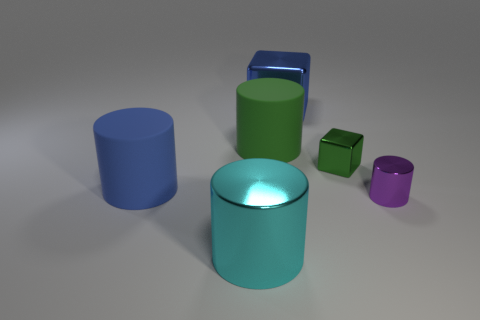What material is the thing that is behind the big blue cylinder and in front of the big green cylinder?
Provide a succinct answer. Metal. Are the cyan cylinder and the blue block that is on the left side of the small purple thing made of the same material?
Your answer should be compact. Yes. Are there any other things that are the same size as the cyan cylinder?
Give a very brief answer. Yes. How many things are either small cubes or cylinders that are in front of the blue rubber cylinder?
Your response must be concise. 3. Is the size of the matte cylinder that is to the right of the cyan shiny cylinder the same as the metal cylinder on the right side of the big block?
Provide a short and direct response. No. How many other things are there of the same color as the big metallic cylinder?
Your answer should be very brief. 0. There is a green cylinder; is its size the same as the cylinder that is to the right of the green cube?
Give a very brief answer. No. There is a blue object behind the large rubber cylinder that is behind the small green metallic block; how big is it?
Offer a terse response. Large. What color is the other tiny object that is the same shape as the blue matte thing?
Give a very brief answer. Purple. Do the purple metallic thing and the green cylinder have the same size?
Offer a very short reply. No. 